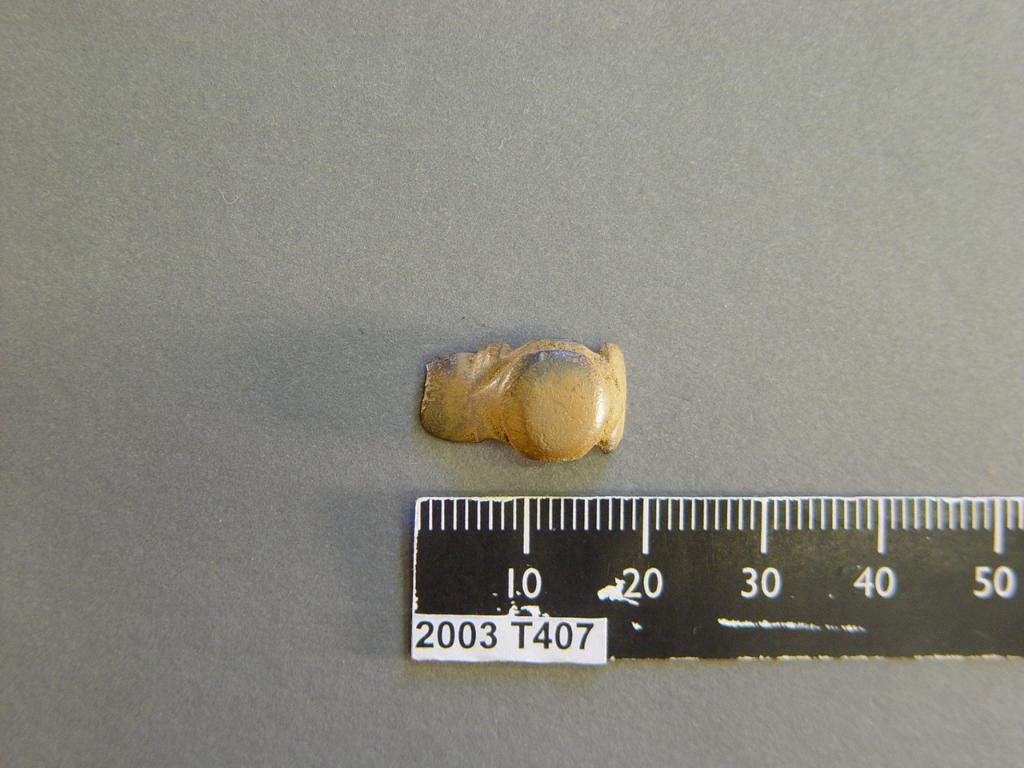How long is the measurement of that?
Make the answer very short. 20. What is the max measurement possible?
Offer a very short reply. 50. 